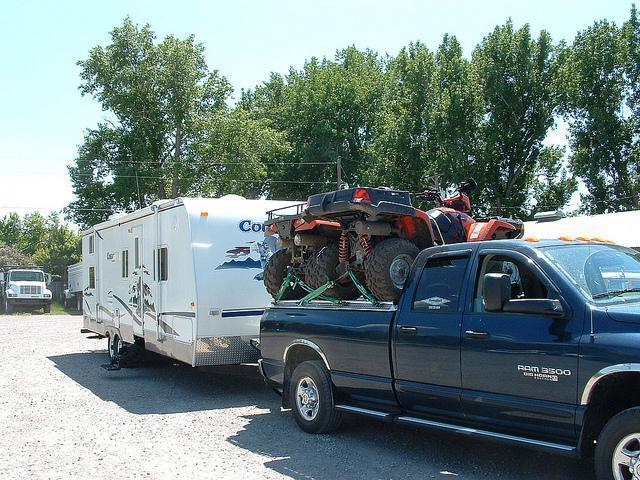How many trucks are visible?
Give a very brief answer. 2. How many people are drinking?
Give a very brief answer. 0. 